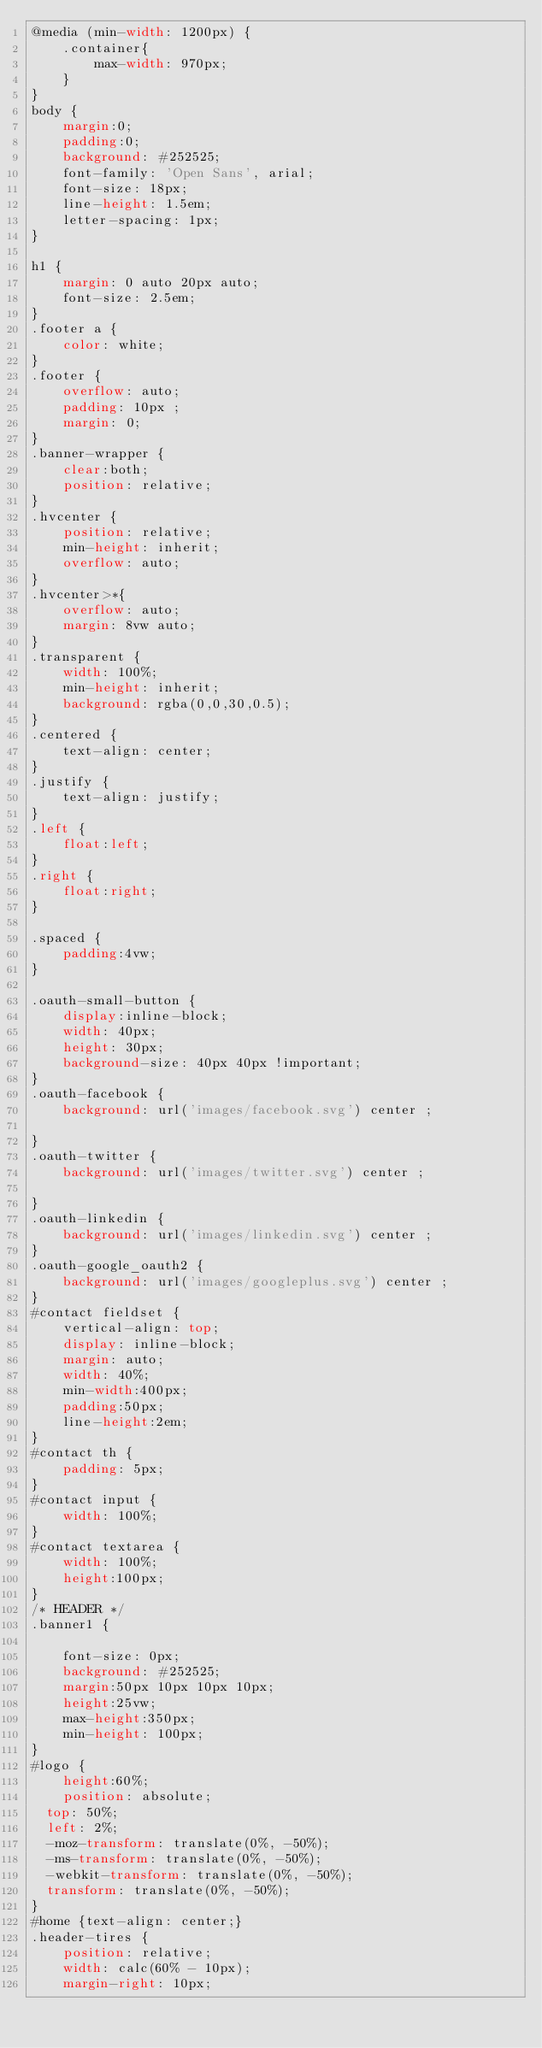<code> <loc_0><loc_0><loc_500><loc_500><_CSS_>@media (min-width: 1200px) {
    .container{
        max-width: 970px;
    }
}
body {
	margin:0;
	padding:0;
	background: #252525;
	font-family: 'Open Sans', arial;
	font-size: 18px;
	line-height: 1.5em;
	letter-spacing: 1px;
}

h1 {
	margin: 0 auto 20px auto;
	font-size: 2.5em;
}
.footer a {
	color: white;
}
.footer {
	overflow: auto;
	padding: 10px ;
	margin: 0;
}
.banner-wrapper {
	clear:both;
	position: relative;
}
.hvcenter {
	position: relative;
	min-height: inherit;
	overflow: auto;
}
.hvcenter>*{
	overflow: auto;
  	margin: 8vw auto;
}
.transparent {
	width: 100%;
	min-height: inherit;
	background: rgba(0,0,30,0.5);
}
.centered {
	text-align: center;
}
.justify {
	text-align: justify;
}
.left {
	float:left;
}
.right {
	float:right;
}

.spaced {
	padding:4vw;
}

.oauth-small-button {
	display:inline-block;
	width: 40px;
	height: 30px;
	background-size: 40px 40px !important;
}
.oauth-facebook {
	background: url('images/facebook.svg') center ;

}
.oauth-twitter {
	background: url('images/twitter.svg') center ;

}
.oauth-linkedin {
	background: url('images/linkedin.svg') center ;
}
.oauth-google_oauth2 {
	background: url('images/googleplus.svg') center ;
}
#contact fieldset {
	vertical-align: top;
	display: inline-block;
	margin: auto;
	width: 40%;
	min-width:400px;
	padding:50px;
	line-height:2em;
}
#contact th {
	padding: 5px;
}
#contact input {
	width: 100%;
}
#contact textarea {
	width: 100%;
	height:100px;
}
/* HEADER */
.banner1 {
	
	font-size: 0px;
	background: #252525;
	margin:50px 10px 10px 10px;
	height:25vw;
	max-height:350px;
	min-height: 100px; 
}
#logo {
	height:60%;
	position: absolute;
  top: 50%;
  left: 2%;
  -moz-transform: translate(0%, -50%);
  -ms-transform: translate(0%, -50%);
  -webkit-transform: translate(0%, -50%);
  transform: translate(0%, -50%);
}
#home {text-align: center;}
.header-tires {
	position: relative;
	width: calc(60% - 10px);
	margin-right: 10px;</code> 